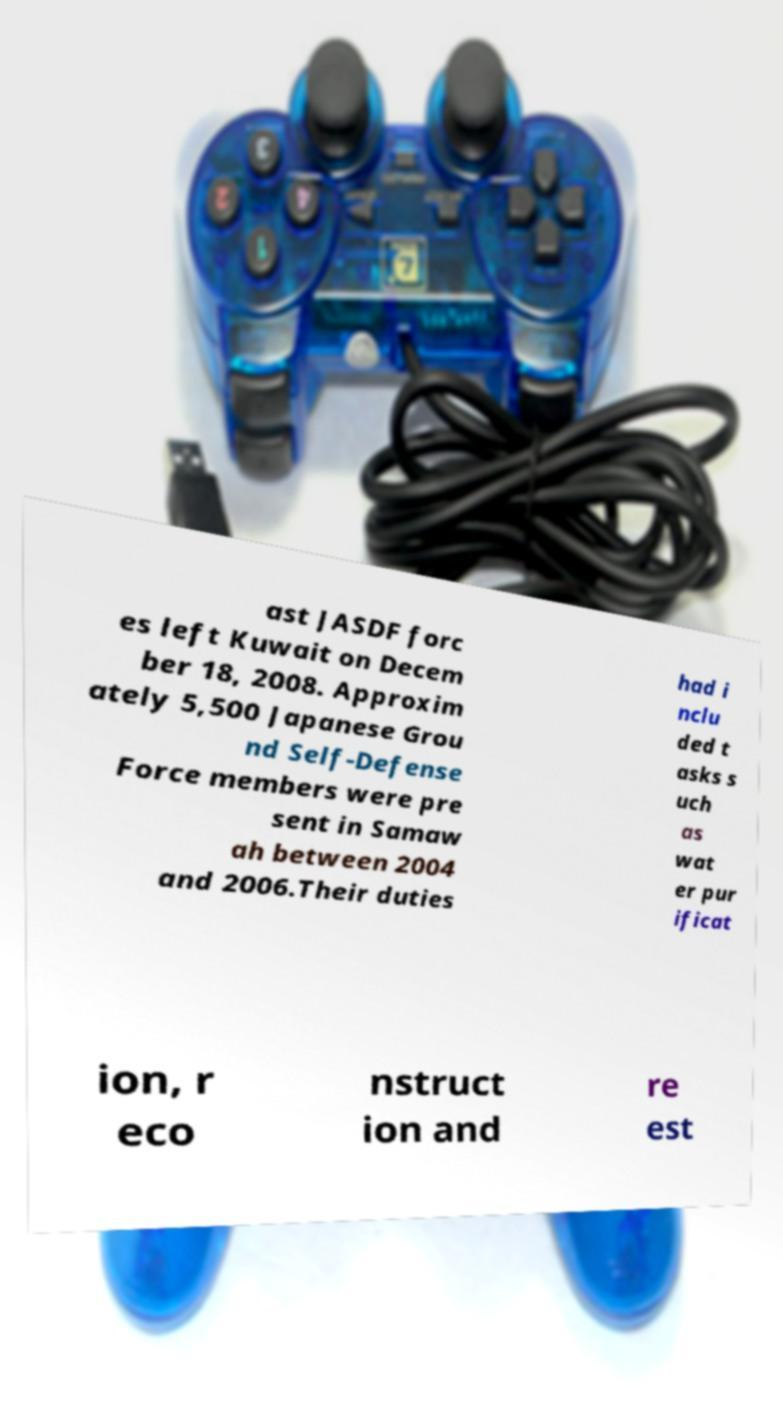I need the written content from this picture converted into text. Can you do that? ast JASDF forc es left Kuwait on Decem ber 18, 2008. Approxim ately 5,500 Japanese Grou nd Self-Defense Force members were pre sent in Samaw ah between 2004 and 2006.Their duties had i nclu ded t asks s uch as wat er pur ificat ion, r eco nstruct ion and re est 